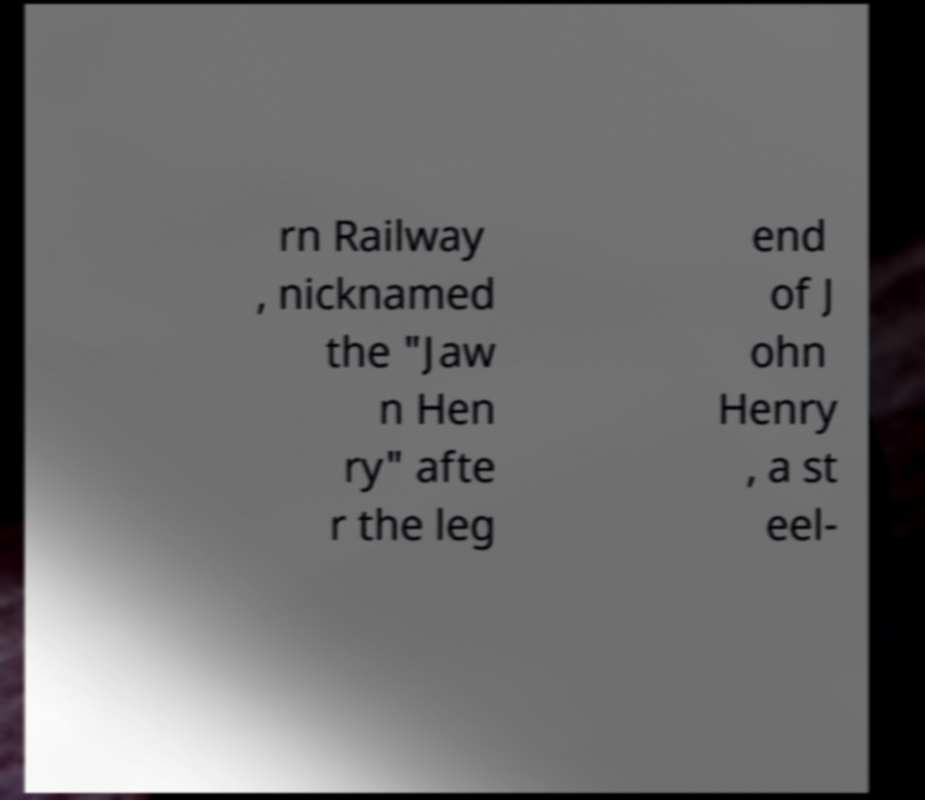What messages or text are displayed in this image? I need them in a readable, typed format. rn Railway , nicknamed the "Jaw n Hen ry" afte r the leg end of J ohn Henry , a st eel- 